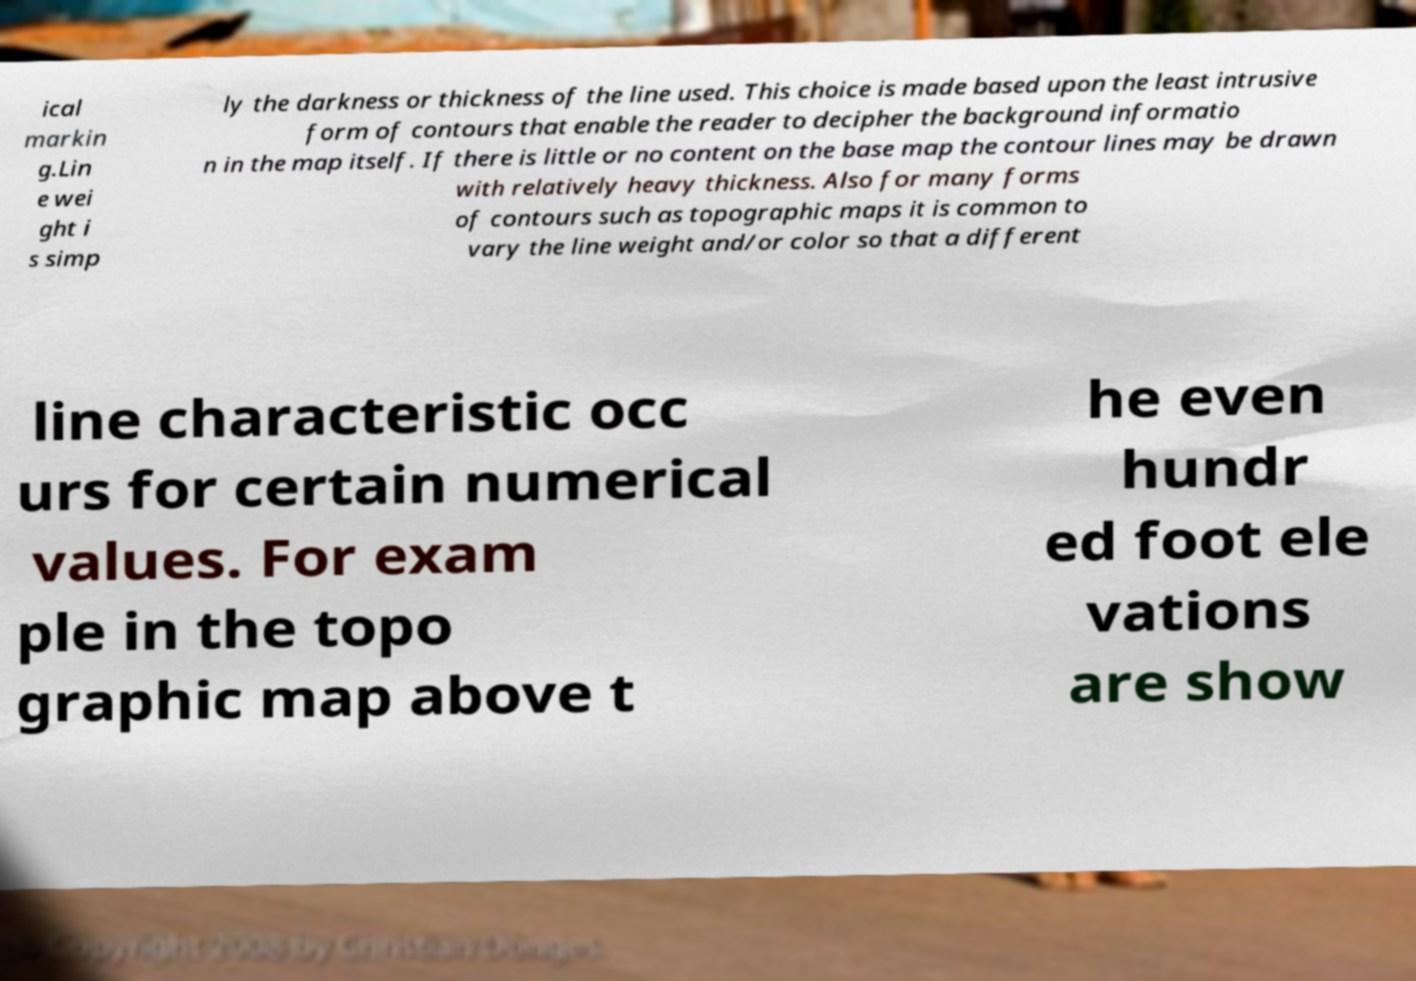Could you assist in decoding the text presented in this image and type it out clearly? ical markin g.Lin e wei ght i s simp ly the darkness or thickness of the line used. This choice is made based upon the least intrusive form of contours that enable the reader to decipher the background informatio n in the map itself. If there is little or no content on the base map the contour lines may be drawn with relatively heavy thickness. Also for many forms of contours such as topographic maps it is common to vary the line weight and/or color so that a different line characteristic occ urs for certain numerical values. For exam ple in the topo graphic map above t he even hundr ed foot ele vations are show 